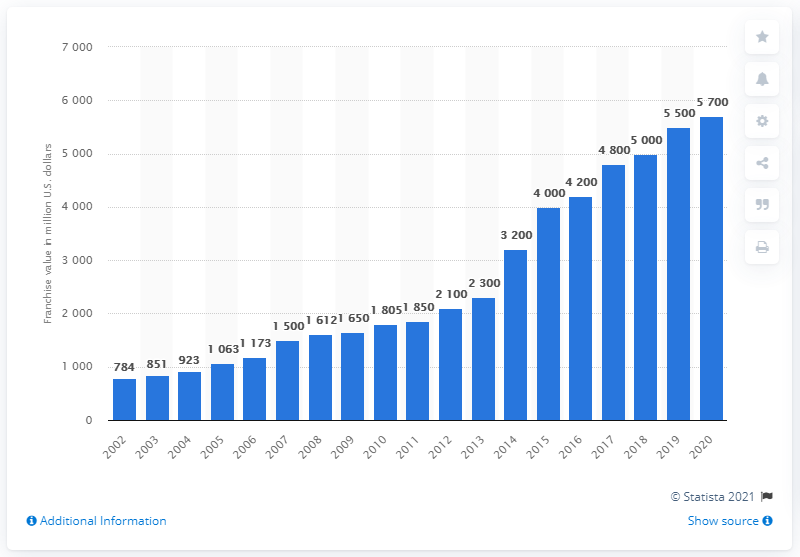List a handful of essential elements in this visual. The franchise value of the Dallas Cowboys in 2020 was 5,700. 